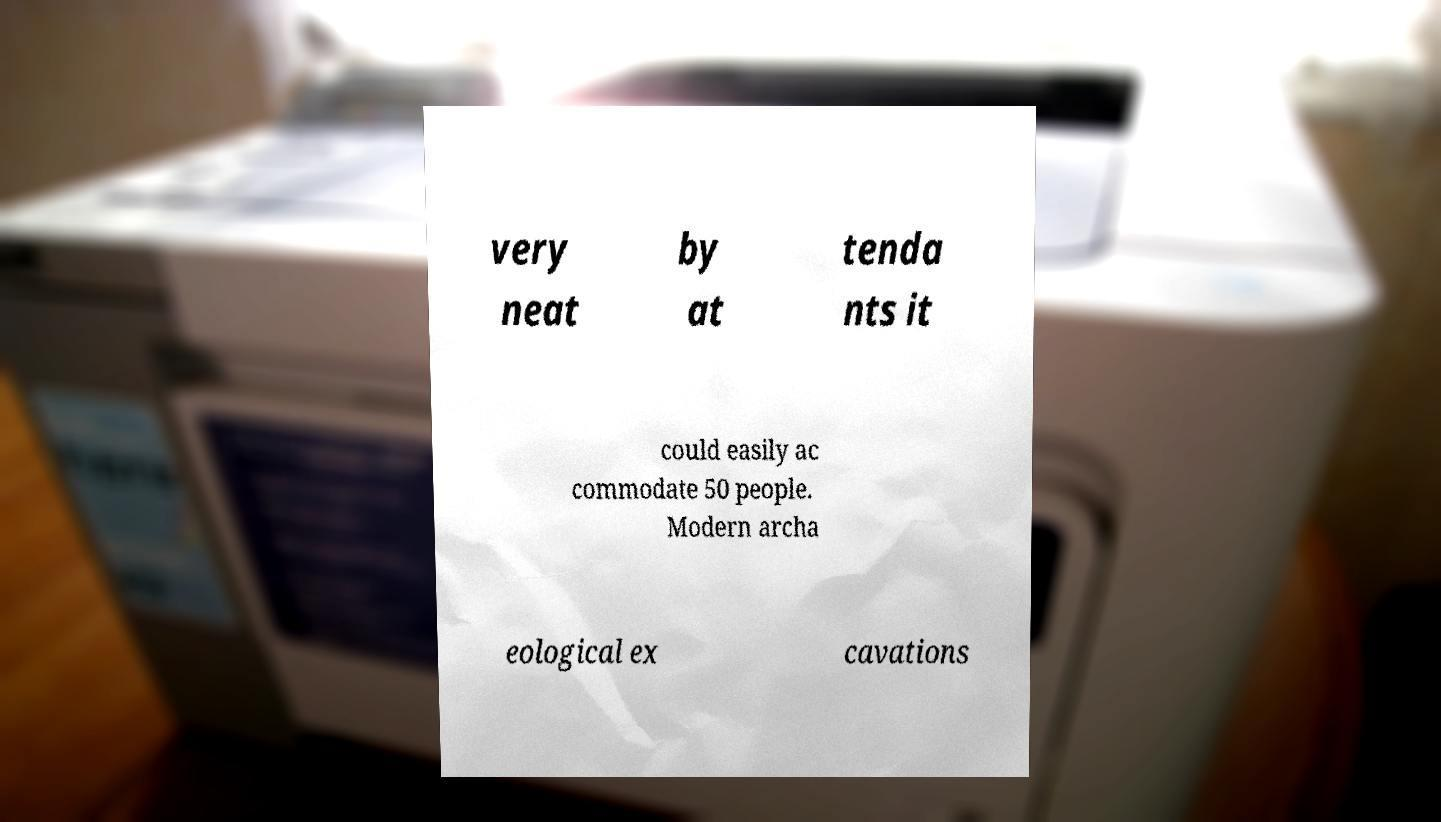There's text embedded in this image that I need extracted. Can you transcribe it verbatim? very neat by at tenda nts it could easily ac commodate 50 people. Modern archa eological ex cavations 